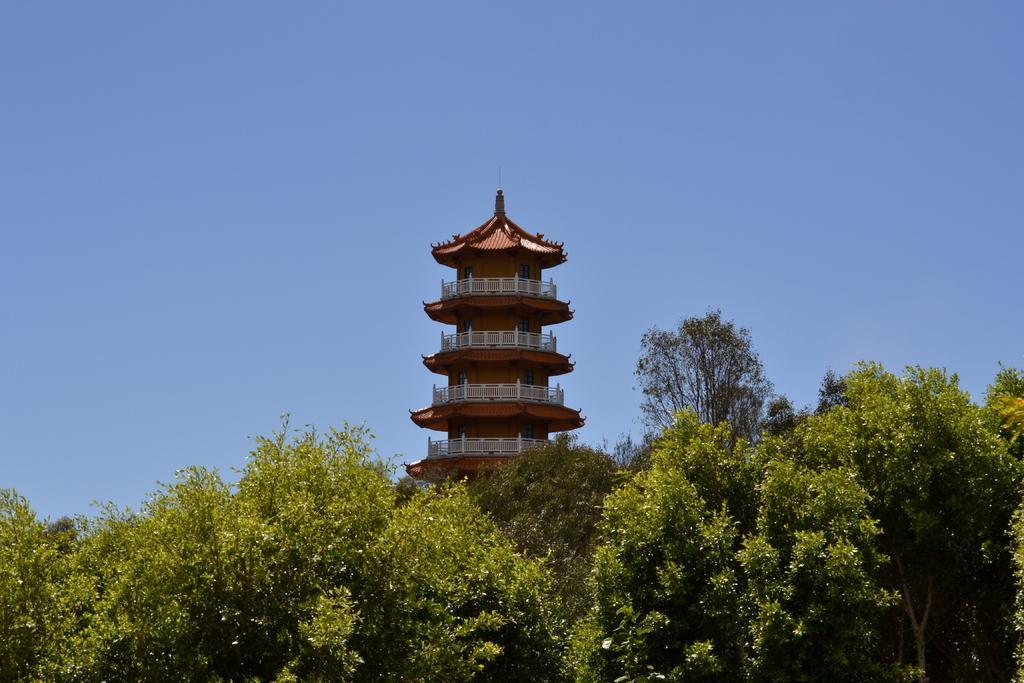Could you give a brief overview of what you see in this image? Here at the bottom there are trees and in the middle we can see a building,windows,fences and this is a sky. 